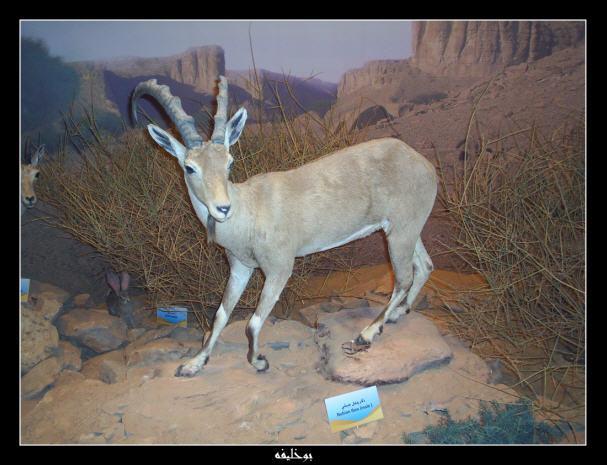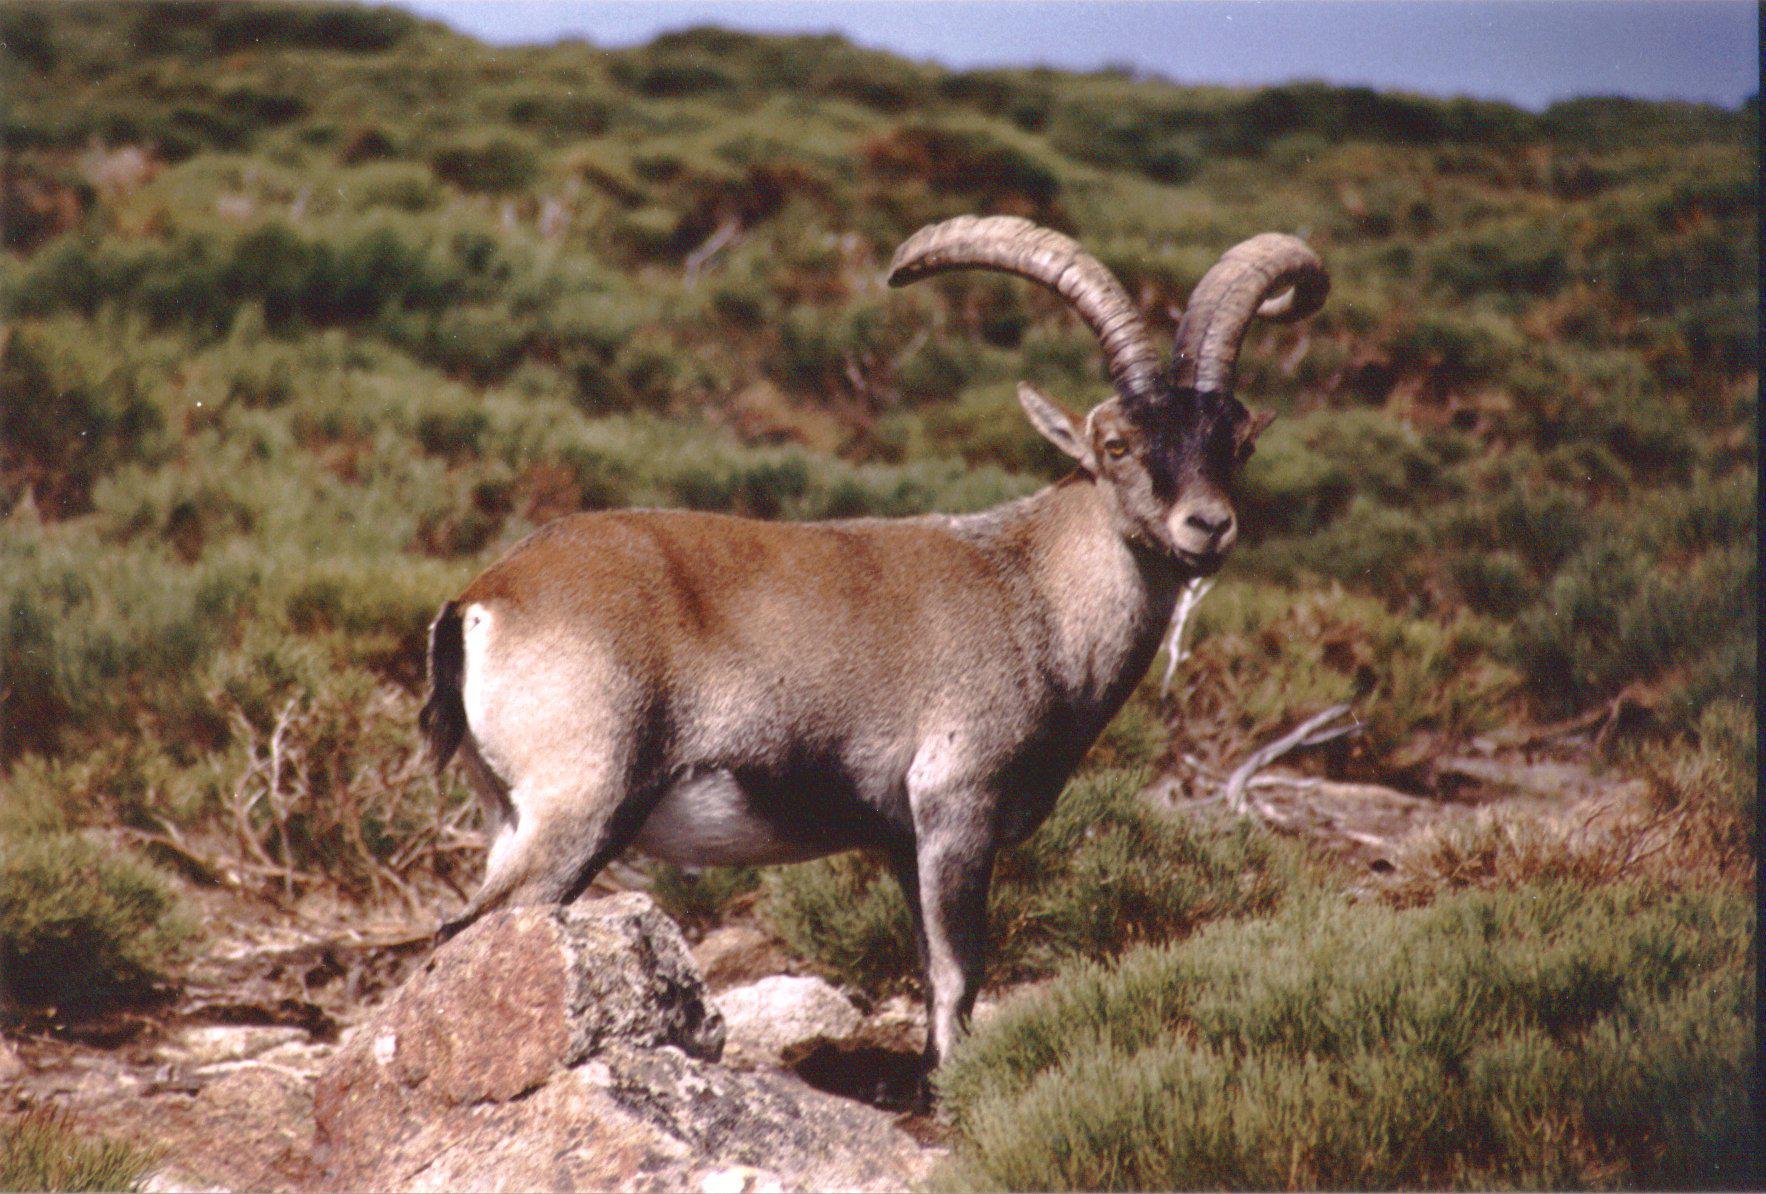The first image is the image on the left, the second image is the image on the right. Evaluate the accuracy of this statement regarding the images: "In one image, at least one horned animal is lying down with its legs tucked under it.". Is it true? Answer yes or no. No. The first image is the image on the left, the second image is the image on the right. Examine the images to the left and right. Is the description "In the left image, one horned animal looks directly at the camera." accurate? Answer yes or no. No. 